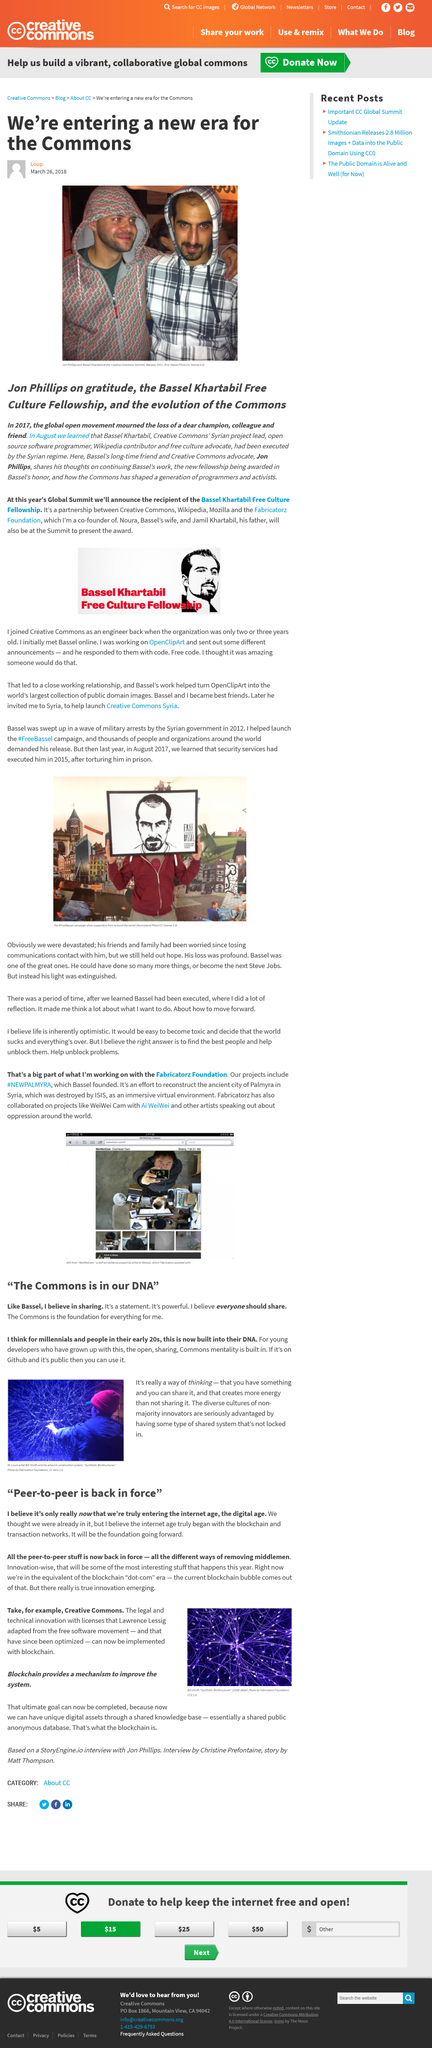Outline some significant characteristics in this image. Bassel Khartabil, a prominent Syrian computer programmer and software developer, was executed by the Syrian regime in 2015. Please use the hashtag #FreeBassel for the campaign. The Bassel Khatibulla Free Culture Fellowship will be announced at this year's Global Summit. Bassel was executed in 2015, and it was only learned about in 2015. The article does not consider a way of "feeling," but instead focuses on a way of "thinking. 